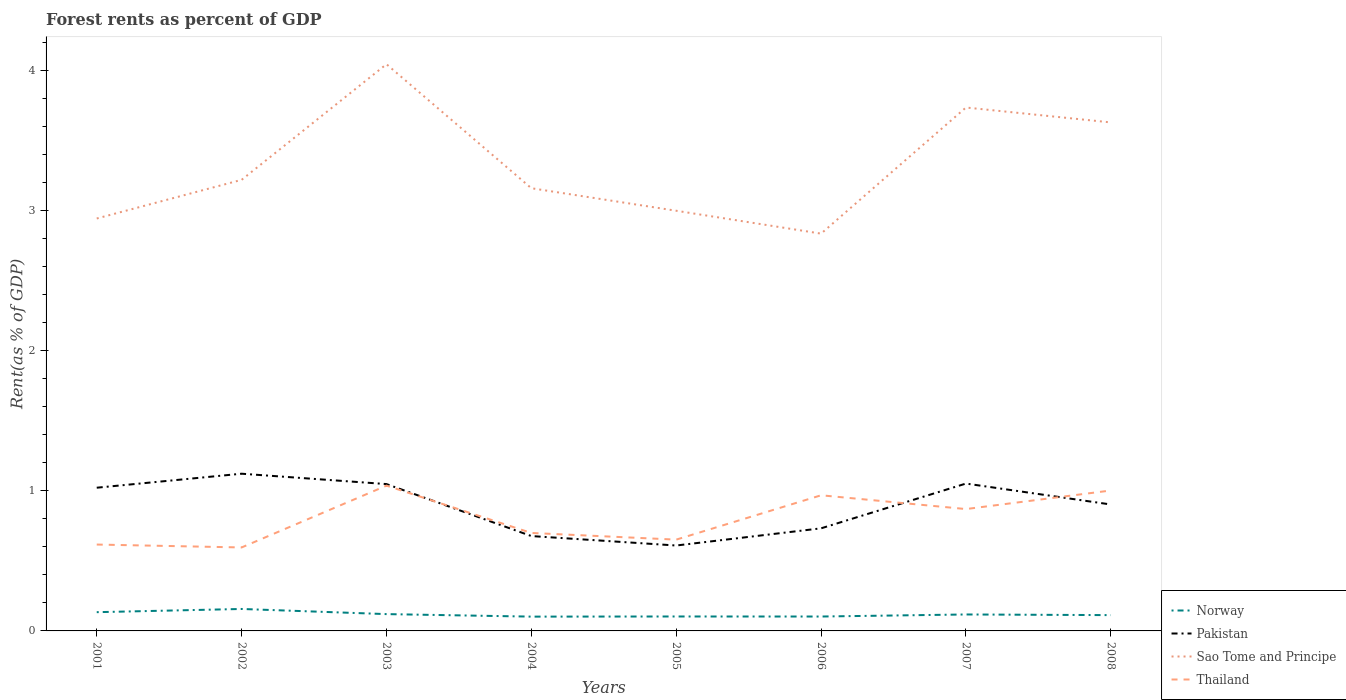How many different coloured lines are there?
Your response must be concise. 4. Does the line corresponding to Pakistan intersect with the line corresponding to Norway?
Make the answer very short. No. Across all years, what is the maximum forest rent in Thailand?
Provide a succinct answer. 0.6. In which year was the forest rent in Thailand maximum?
Your answer should be compact. 2002. What is the total forest rent in Thailand in the graph?
Ensure brevity in your answer.  0.02. What is the difference between the highest and the second highest forest rent in Thailand?
Ensure brevity in your answer.  0.44. Is the forest rent in Pakistan strictly greater than the forest rent in Sao Tome and Principe over the years?
Your answer should be compact. Yes. Does the graph contain any zero values?
Keep it short and to the point. No. How many legend labels are there?
Ensure brevity in your answer.  4. How are the legend labels stacked?
Provide a short and direct response. Vertical. What is the title of the graph?
Offer a terse response. Forest rents as percent of GDP. Does "American Samoa" appear as one of the legend labels in the graph?
Provide a succinct answer. No. What is the label or title of the Y-axis?
Offer a terse response. Rent(as % of GDP). What is the Rent(as % of GDP) in Norway in 2001?
Your answer should be compact. 0.13. What is the Rent(as % of GDP) of Pakistan in 2001?
Ensure brevity in your answer.  1.02. What is the Rent(as % of GDP) of Sao Tome and Principe in 2001?
Give a very brief answer. 2.95. What is the Rent(as % of GDP) in Thailand in 2001?
Your answer should be compact. 0.62. What is the Rent(as % of GDP) of Norway in 2002?
Provide a succinct answer. 0.16. What is the Rent(as % of GDP) in Pakistan in 2002?
Offer a terse response. 1.12. What is the Rent(as % of GDP) in Sao Tome and Principe in 2002?
Offer a terse response. 3.22. What is the Rent(as % of GDP) of Thailand in 2002?
Give a very brief answer. 0.6. What is the Rent(as % of GDP) of Norway in 2003?
Your response must be concise. 0.12. What is the Rent(as % of GDP) of Pakistan in 2003?
Your response must be concise. 1.05. What is the Rent(as % of GDP) of Sao Tome and Principe in 2003?
Offer a very short reply. 4.05. What is the Rent(as % of GDP) in Thailand in 2003?
Your answer should be compact. 1.04. What is the Rent(as % of GDP) in Norway in 2004?
Give a very brief answer. 0.1. What is the Rent(as % of GDP) in Pakistan in 2004?
Provide a succinct answer. 0.68. What is the Rent(as % of GDP) in Sao Tome and Principe in 2004?
Offer a very short reply. 3.16. What is the Rent(as % of GDP) in Thailand in 2004?
Provide a short and direct response. 0.7. What is the Rent(as % of GDP) in Norway in 2005?
Offer a terse response. 0.1. What is the Rent(as % of GDP) in Pakistan in 2005?
Keep it short and to the point. 0.61. What is the Rent(as % of GDP) in Sao Tome and Principe in 2005?
Offer a terse response. 3. What is the Rent(as % of GDP) in Thailand in 2005?
Give a very brief answer. 0.65. What is the Rent(as % of GDP) in Norway in 2006?
Keep it short and to the point. 0.1. What is the Rent(as % of GDP) in Pakistan in 2006?
Give a very brief answer. 0.73. What is the Rent(as % of GDP) in Sao Tome and Principe in 2006?
Ensure brevity in your answer.  2.84. What is the Rent(as % of GDP) of Thailand in 2006?
Offer a terse response. 0.97. What is the Rent(as % of GDP) of Norway in 2007?
Ensure brevity in your answer.  0.12. What is the Rent(as % of GDP) in Pakistan in 2007?
Keep it short and to the point. 1.05. What is the Rent(as % of GDP) of Sao Tome and Principe in 2007?
Provide a short and direct response. 3.74. What is the Rent(as % of GDP) of Thailand in 2007?
Give a very brief answer. 0.87. What is the Rent(as % of GDP) of Norway in 2008?
Your answer should be very brief. 0.11. What is the Rent(as % of GDP) of Pakistan in 2008?
Your answer should be very brief. 0.9. What is the Rent(as % of GDP) in Sao Tome and Principe in 2008?
Provide a succinct answer. 3.63. What is the Rent(as % of GDP) of Thailand in 2008?
Your response must be concise. 1. Across all years, what is the maximum Rent(as % of GDP) of Norway?
Ensure brevity in your answer.  0.16. Across all years, what is the maximum Rent(as % of GDP) of Pakistan?
Ensure brevity in your answer.  1.12. Across all years, what is the maximum Rent(as % of GDP) of Sao Tome and Principe?
Make the answer very short. 4.05. Across all years, what is the maximum Rent(as % of GDP) in Thailand?
Offer a very short reply. 1.04. Across all years, what is the minimum Rent(as % of GDP) in Norway?
Your answer should be very brief. 0.1. Across all years, what is the minimum Rent(as % of GDP) of Pakistan?
Make the answer very short. 0.61. Across all years, what is the minimum Rent(as % of GDP) in Sao Tome and Principe?
Give a very brief answer. 2.84. Across all years, what is the minimum Rent(as % of GDP) of Thailand?
Ensure brevity in your answer.  0.6. What is the total Rent(as % of GDP) of Norway in the graph?
Keep it short and to the point. 0.95. What is the total Rent(as % of GDP) in Pakistan in the graph?
Offer a very short reply. 7.17. What is the total Rent(as % of GDP) of Sao Tome and Principe in the graph?
Ensure brevity in your answer.  26.58. What is the total Rent(as % of GDP) of Thailand in the graph?
Provide a succinct answer. 6.44. What is the difference between the Rent(as % of GDP) in Norway in 2001 and that in 2002?
Give a very brief answer. -0.02. What is the difference between the Rent(as % of GDP) of Pakistan in 2001 and that in 2002?
Offer a very short reply. -0.1. What is the difference between the Rent(as % of GDP) of Sao Tome and Principe in 2001 and that in 2002?
Your answer should be compact. -0.28. What is the difference between the Rent(as % of GDP) in Thailand in 2001 and that in 2002?
Your response must be concise. 0.02. What is the difference between the Rent(as % of GDP) of Norway in 2001 and that in 2003?
Make the answer very short. 0.01. What is the difference between the Rent(as % of GDP) in Pakistan in 2001 and that in 2003?
Make the answer very short. -0.03. What is the difference between the Rent(as % of GDP) of Sao Tome and Principe in 2001 and that in 2003?
Your answer should be compact. -1.1. What is the difference between the Rent(as % of GDP) of Thailand in 2001 and that in 2003?
Keep it short and to the point. -0.42. What is the difference between the Rent(as % of GDP) of Norway in 2001 and that in 2004?
Offer a terse response. 0.03. What is the difference between the Rent(as % of GDP) in Pakistan in 2001 and that in 2004?
Give a very brief answer. 0.35. What is the difference between the Rent(as % of GDP) of Sao Tome and Principe in 2001 and that in 2004?
Your answer should be very brief. -0.22. What is the difference between the Rent(as % of GDP) of Thailand in 2001 and that in 2004?
Offer a terse response. -0.08. What is the difference between the Rent(as % of GDP) in Norway in 2001 and that in 2005?
Provide a short and direct response. 0.03. What is the difference between the Rent(as % of GDP) in Pakistan in 2001 and that in 2005?
Make the answer very short. 0.41. What is the difference between the Rent(as % of GDP) of Sao Tome and Principe in 2001 and that in 2005?
Give a very brief answer. -0.06. What is the difference between the Rent(as % of GDP) in Thailand in 2001 and that in 2005?
Your answer should be compact. -0.04. What is the difference between the Rent(as % of GDP) of Norway in 2001 and that in 2006?
Make the answer very short. 0.03. What is the difference between the Rent(as % of GDP) in Pakistan in 2001 and that in 2006?
Ensure brevity in your answer.  0.29. What is the difference between the Rent(as % of GDP) in Sao Tome and Principe in 2001 and that in 2006?
Provide a short and direct response. 0.11. What is the difference between the Rent(as % of GDP) of Thailand in 2001 and that in 2006?
Ensure brevity in your answer.  -0.35. What is the difference between the Rent(as % of GDP) in Norway in 2001 and that in 2007?
Provide a short and direct response. 0.02. What is the difference between the Rent(as % of GDP) in Pakistan in 2001 and that in 2007?
Keep it short and to the point. -0.03. What is the difference between the Rent(as % of GDP) of Sao Tome and Principe in 2001 and that in 2007?
Keep it short and to the point. -0.79. What is the difference between the Rent(as % of GDP) in Thailand in 2001 and that in 2007?
Your answer should be compact. -0.25. What is the difference between the Rent(as % of GDP) in Norway in 2001 and that in 2008?
Your response must be concise. 0.02. What is the difference between the Rent(as % of GDP) of Pakistan in 2001 and that in 2008?
Provide a short and direct response. 0.12. What is the difference between the Rent(as % of GDP) of Sao Tome and Principe in 2001 and that in 2008?
Provide a succinct answer. -0.69. What is the difference between the Rent(as % of GDP) in Thailand in 2001 and that in 2008?
Give a very brief answer. -0.39. What is the difference between the Rent(as % of GDP) in Norway in 2002 and that in 2003?
Provide a short and direct response. 0.04. What is the difference between the Rent(as % of GDP) of Pakistan in 2002 and that in 2003?
Offer a very short reply. 0.07. What is the difference between the Rent(as % of GDP) in Sao Tome and Principe in 2002 and that in 2003?
Keep it short and to the point. -0.83. What is the difference between the Rent(as % of GDP) in Thailand in 2002 and that in 2003?
Provide a succinct answer. -0.44. What is the difference between the Rent(as % of GDP) of Norway in 2002 and that in 2004?
Give a very brief answer. 0.05. What is the difference between the Rent(as % of GDP) of Pakistan in 2002 and that in 2004?
Make the answer very short. 0.45. What is the difference between the Rent(as % of GDP) in Sao Tome and Principe in 2002 and that in 2004?
Offer a very short reply. 0.06. What is the difference between the Rent(as % of GDP) of Thailand in 2002 and that in 2004?
Your answer should be very brief. -0.1. What is the difference between the Rent(as % of GDP) in Norway in 2002 and that in 2005?
Make the answer very short. 0.05. What is the difference between the Rent(as % of GDP) in Pakistan in 2002 and that in 2005?
Your answer should be very brief. 0.51. What is the difference between the Rent(as % of GDP) in Sao Tome and Principe in 2002 and that in 2005?
Offer a terse response. 0.22. What is the difference between the Rent(as % of GDP) of Thailand in 2002 and that in 2005?
Give a very brief answer. -0.06. What is the difference between the Rent(as % of GDP) of Norway in 2002 and that in 2006?
Your answer should be compact. 0.05. What is the difference between the Rent(as % of GDP) in Pakistan in 2002 and that in 2006?
Give a very brief answer. 0.39. What is the difference between the Rent(as % of GDP) of Sao Tome and Principe in 2002 and that in 2006?
Ensure brevity in your answer.  0.38. What is the difference between the Rent(as % of GDP) of Thailand in 2002 and that in 2006?
Your answer should be compact. -0.37. What is the difference between the Rent(as % of GDP) in Norway in 2002 and that in 2007?
Offer a very short reply. 0.04. What is the difference between the Rent(as % of GDP) of Pakistan in 2002 and that in 2007?
Give a very brief answer. 0.07. What is the difference between the Rent(as % of GDP) in Sao Tome and Principe in 2002 and that in 2007?
Your response must be concise. -0.52. What is the difference between the Rent(as % of GDP) in Thailand in 2002 and that in 2007?
Ensure brevity in your answer.  -0.27. What is the difference between the Rent(as % of GDP) in Norway in 2002 and that in 2008?
Offer a terse response. 0.04. What is the difference between the Rent(as % of GDP) in Pakistan in 2002 and that in 2008?
Your response must be concise. 0.22. What is the difference between the Rent(as % of GDP) in Sao Tome and Principe in 2002 and that in 2008?
Provide a short and direct response. -0.41. What is the difference between the Rent(as % of GDP) in Thailand in 2002 and that in 2008?
Give a very brief answer. -0.41. What is the difference between the Rent(as % of GDP) of Norway in 2003 and that in 2004?
Your response must be concise. 0.02. What is the difference between the Rent(as % of GDP) in Pakistan in 2003 and that in 2004?
Make the answer very short. 0.37. What is the difference between the Rent(as % of GDP) of Sao Tome and Principe in 2003 and that in 2004?
Your response must be concise. 0.89. What is the difference between the Rent(as % of GDP) in Thailand in 2003 and that in 2004?
Provide a short and direct response. 0.34. What is the difference between the Rent(as % of GDP) in Norway in 2003 and that in 2005?
Ensure brevity in your answer.  0.02. What is the difference between the Rent(as % of GDP) in Pakistan in 2003 and that in 2005?
Offer a terse response. 0.44. What is the difference between the Rent(as % of GDP) of Sao Tome and Principe in 2003 and that in 2005?
Ensure brevity in your answer.  1.05. What is the difference between the Rent(as % of GDP) in Thailand in 2003 and that in 2005?
Your response must be concise. 0.39. What is the difference between the Rent(as % of GDP) in Norway in 2003 and that in 2006?
Provide a short and direct response. 0.02. What is the difference between the Rent(as % of GDP) of Pakistan in 2003 and that in 2006?
Offer a terse response. 0.32. What is the difference between the Rent(as % of GDP) of Sao Tome and Principe in 2003 and that in 2006?
Offer a very short reply. 1.21. What is the difference between the Rent(as % of GDP) in Thailand in 2003 and that in 2006?
Your response must be concise. 0.07. What is the difference between the Rent(as % of GDP) of Norway in 2003 and that in 2007?
Ensure brevity in your answer.  0. What is the difference between the Rent(as % of GDP) of Pakistan in 2003 and that in 2007?
Your answer should be compact. -0. What is the difference between the Rent(as % of GDP) in Sao Tome and Principe in 2003 and that in 2007?
Offer a very short reply. 0.31. What is the difference between the Rent(as % of GDP) of Thailand in 2003 and that in 2007?
Keep it short and to the point. 0.17. What is the difference between the Rent(as % of GDP) of Norway in 2003 and that in 2008?
Your answer should be very brief. 0.01. What is the difference between the Rent(as % of GDP) in Pakistan in 2003 and that in 2008?
Make the answer very short. 0.15. What is the difference between the Rent(as % of GDP) of Sao Tome and Principe in 2003 and that in 2008?
Provide a succinct answer. 0.42. What is the difference between the Rent(as % of GDP) of Thailand in 2003 and that in 2008?
Keep it short and to the point. 0.03. What is the difference between the Rent(as % of GDP) of Norway in 2004 and that in 2005?
Give a very brief answer. -0. What is the difference between the Rent(as % of GDP) in Pakistan in 2004 and that in 2005?
Your answer should be compact. 0.07. What is the difference between the Rent(as % of GDP) of Sao Tome and Principe in 2004 and that in 2005?
Give a very brief answer. 0.16. What is the difference between the Rent(as % of GDP) in Thailand in 2004 and that in 2005?
Make the answer very short. 0.05. What is the difference between the Rent(as % of GDP) of Norway in 2004 and that in 2006?
Offer a terse response. -0. What is the difference between the Rent(as % of GDP) in Pakistan in 2004 and that in 2006?
Make the answer very short. -0.06. What is the difference between the Rent(as % of GDP) of Sao Tome and Principe in 2004 and that in 2006?
Provide a succinct answer. 0.32. What is the difference between the Rent(as % of GDP) of Thailand in 2004 and that in 2006?
Keep it short and to the point. -0.27. What is the difference between the Rent(as % of GDP) of Norway in 2004 and that in 2007?
Offer a terse response. -0.02. What is the difference between the Rent(as % of GDP) of Pakistan in 2004 and that in 2007?
Provide a succinct answer. -0.38. What is the difference between the Rent(as % of GDP) in Sao Tome and Principe in 2004 and that in 2007?
Your response must be concise. -0.58. What is the difference between the Rent(as % of GDP) of Thailand in 2004 and that in 2007?
Keep it short and to the point. -0.17. What is the difference between the Rent(as % of GDP) of Norway in 2004 and that in 2008?
Give a very brief answer. -0.01. What is the difference between the Rent(as % of GDP) in Pakistan in 2004 and that in 2008?
Provide a short and direct response. -0.23. What is the difference between the Rent(as % of GDP) in Sao Tome and Principe in 2004 and that in 2008?
Your response must be concise. -0.47. What is the difference between the Rent(as % of GDP) of Thailand in 2004 and that in 2008?
Give a very brief answer. -0.3. What is the difference between the Rent(as % of GDP) in Norway in 2005 and that in 2006?
Your answer should be very brief. 0. What is the difference between the Rent(as % of GDP) of Pakistan in 2005 and that in 2006?
Your response must be concise. -0.12. What is the difference between the Rent(as % of GDP) in Sao Tome and Principe in 2005 and that in 2006?
Provide a short and direct response. 0.16. What is the difference between the Rent(as % of GDP) of Thailand in 2005 and that in 2006?
Provide a succinct answer. -0.32. What is the difference between the Rent(as % of GDP) in Norway in 2005 and that in 2007?
Keep it short and to the point. -0.01. What is the difference between the Rent(as % of GDP) in Pakistan in 2005 and that in 2007?
Your response must be concise. -0.44. What is the difference between the Rent(as % of GDP) of Sao Tome and Principe in 2005 and that in 2007?
Ensure brevity in your answer.  -0.74. What is the difference between the Rent(as % of GDP) of Thailand in 2005 and that in 2007?
Keep it short and to the point. -0.22. What is the difference between the Rent(as % of GDP) in Norway in 2005 and that in 2008?
Keep it short and to the point. -0.01. What is the difference between the Rent(as % of GDP) in Pakistan in 2005 and that in 2008?
Make the answer very short. -0.29. What is the difference between the Rent(as % of GDP) in Sao Tome and Principe in 2005 and that in 2008?
Your response must be concise. -0.63. What is the difference between the Rent(as % of GDP) in Thailand in 2005 and that in 2008?
Make the answer very short. -0.35. What is the difference between the Rent(as % of GDP) in Norway in 2006 and that in 2007?
Offer a very short reply. -0.01. What is the difference between the Rent(as % of GDP) of Pakistan in 2006 and that in 2007?
Your response must be concise. -0.32. What is the difference between the Rent(as % of GDP) of Sao Tome and Principe in 2006 and that in 2007?
Provide a short and direct response. -0.9. What is the difference between the Rent(as % of GDP) in Thailand in 2006 and that in 2007?
Provide a short and direct response. 0.1. What is the difference between the Rent(as % of GDP) of Norway in 2006 and that in 2008?
Offer a very short reply. -0.01. What is the difference between the Rent(as % of GDP) in Pakistan in 2006 and that in 2008?
Give a very brief answer. -0.17. What is the difference between the Rent(as % of GDP) in Sao Tome and Principe in 2006 and that in 2008?
Make the answer very short. -0.79. What is the difference between the Rent(as % of GDP) in Thailand in 2006 and that in 2008?
Your answer should be compact. -0.03. What is the difference between the Rent(as % of GDP) in Norway in 2007 and that in 2008?
Give a very brief answer. 0. What is the difference between the Rent(as % of GDP) in Pakistan in 2007 and that in 2008?
Keep it short and to the point. 0.15. What is the difference between the Rent(as % of GDP) in Sao Tome and Principe in 2007 and that in 2008?
Provide a succinct answer. 0.11. What is the difference between the Rent(as % of GDP) in Thailand in 2007 and that in 2008?
Keep it short and to the point. -0.13. What is the difference between the Rent(as % of GDP) in Norway in 2001 and the Rent(as % of GDP) in Pakistan in 2002?
Offer a very short reply. -0.99. What is the difference between the Rent(as % of GDP) in Norway in 2001 and the Rent(as % of GDP) in Sao Tome and Principe in 2002?
Your answer should be very brief. -3.09. What is the difference between the Rent(as % of GDP) of Norway in 2001 and the Rent(as % of GDP) of Thailand in 2002?
Provide a succinct answer. -0.46. What is the difference between the Rent(as % of GDP) of Pakistan in 2001 and the Rent(as % of GDP) of Sao Tome and Principe in 2002?
Your answer should be compact. -2.2. What is the difference between the Rent(as % of GDP) in Pakistan in 2001 and the Rent(as % of GDP) in Thailand in 2002?
Offer a terse response. 0.43. What is the difference between the Rent(as % of GDP) of Sao Tome and Principe in 2001 and the Rent(as % of GDP) of Thailand in 2002?
Your response must be concise. 2.35. What is the difference between the Rent(as % of GDP) of Norway in 2001 and the Rent(as % of GDP) of Pakistan in 2003?
Ensure brevity in your answer.  -0.91. What is the difference between the Rent(as % of GDP) in Norway in 2001 and the Rent(as % of GDP) in Sao Tome and Principe in 2003?
Ensure brevity in your answer.  -3.91. What is the difference between the Rent(as % of GDP) in Norway in 2001 and the Rent(as % of GDP) in Thailand in 2003?
Your response must be concise. -0.9. What is the difference between the Rent(as % of GDP) of Pakistan in 2001 and the Rent(as % of GDP) of Sao Tome and Principe in 2003?
Your answer should be compact. -3.02. What is the difference between the Rent(as % of GDP) of Pakistan in 2001 and the Rent(as % of GDP) of Thailand in 2003?
Make the answer very short. -0.01. What is the difference between the Rent(as % of GDP) in Sao Tome and Principe in 2001 and the Rent(as % of GDP) in Thailand in 2003?
Provide a short and direct response. 1.91. What is the difference between the Rent(as % of GDP) of Norway in 2001 and the Rent(as % of GDP) of Pakistan in 2004?
Keep it short and to the point. -0.54. What is the difference between the Rent(as % of GDP) in Norway in 2001 and the Rent(as % of GDP) in Sao Tome and Principe in 2004?
Your answer should be compact. -3.03. What is the difference between the Rent(as % of GDP) in Norway in 2001 and the Rent(as % of GDP) in Thailand in 2004?
Provide a succinct answer. -0.57. What is the difference between the Rent(as % of GDP) in Pakistan in 2001 and the Rent(as % of GDP) in Sao Tome and Principe in 2004?
Offer a terse response. -2.14. What is the difference between the Rent(as % of GDP) of Pakistan in 2001 and the Rent(as % of GDP) of Thailand in 2004?
Ensure brevity in your answer.  0.32. What is the difference between the Rent(as % of GDP) in Sao Tome and Principe in 2001 and the Rent(as % of GDP) in Thailand in 2004?
Your answer should be compact. 2.25. What is the difference between the Rent(as % of GDP) in Norway in 2001 and the Rent(as % of GDP) in Pakistan in 2005?
Offer a very short reply. -0.48. What is the difference between the Rent(as % of GDP) in Norway in 2001 and the Rent(as % of GDP) in Sao Tome and Principe in 2005?
Keep it short and to the point. -2.87. What is the difference between the Rent(as % of GDP) in Norway in 2001 and the Rent(as % of GDP) in Thailand in 2005?
Offer a very short reply. -0.52. What is the difference between the Rent(as % of GDP) in Pakistan in 2001 and the Rent(as % of GDP) in Sao Tome and Principe in 2005?
Give a very brief answer. -1.98. What is the difference between the Rent(as % of GDP) of Pakistan in 2001 and the Rent(as % of GDP) of Thailand in 2005?
Your answer should be very brief. 0.37. What is the difference between the Rent(as % of GDP) in Sao Tome and Principe in 2001 and the Rent(as % of GDP) in Thailand in 2005?
Your answer should be very brief. 2.29. What is the difference between the Rent(as % of GDP) in Norway in 2001 and the Rent(as % of GDP) in Pakistan in 2006?
Your response must be concise. -0.6. What is the difference between the Rent(as % of GDP) of Norway in 2001 and the Rent(as % of GDP) of Sao Tome and Principe in 2006?
Keep it short and to the point. -2.7. What is the difference between the Rent(as % of GDP) in Norway in 2001 and the Rent(as % of GDP) in Thailand in 2006?
Give a very brief answer. -0.83. What is the difference between the Rent(as % of GDP) in Pakistan in 2001 and the Rent(as % of GDP) in Sao Tome and Principe in 2006?
Offer a very short reply. -1.81. What is the difference between the Rent(as % of GDP) of Pakistan in 2001 and the Rent(as % of GDP) of Thailand in 2006?
Keep it short and to the point. 0.05. What is the difference between the Rent(as % of GDP) in Sao Tome and Principe in 2001 and the Rent(as % of GDP) in Thailand in 2006?
Ensure brevity in your answer.  1.98. What is the difference between the Rent(as % of GDP) of Norway in 2001 and the Rent(as % of GDP) of Pakistan in 2007?
Keep it short and to the point. -0.92. What is the difference between the Rent(as % of GDP) of Norway in 2001 and the Rent(as % of GDP) of Sao Tome and Principe in 2007?
Give a very brief answer. -3.6. What is the difference between the Rent(as % of GDP) in Norway in 2001 and the Rent(as % of GDP) in Thailand in 2007?
Ensure brevity in your answer.  -0.74. What is the difference between the Rent(as % of GDP) of Pakistan in 2001 and the Rent(as % of GDP) of Sao Tome and Principe in 2007?
Keep it short and to the point. -2.72. What is the difference between the Rent(as % of GDP) in Pakistan in 2001 and the Rent(as % of GDP) in Thailand in 2007?
Your answer should be compact. 0.15. What is the difference between the Rent(as % of GDP) of Sao Tome and Principe in 2001 and the Rent(as % of GDP) of Thailand in 2007?
Your response must be concise. 2.08. What is the difference between the Rent(as % of GDP) in Norway in 2001 and the Rent(as % of GDP) in Pakistan in 2008?
Your answer should be compact. -0.77. What is the difference between the Rent(as % of GDP) in Norway in 2001 and the Rent(as % of GDP) in Sao Tome and Principe in 2008?
Give a very brief answer. -3.5. What is the difference between the Rent(as % of GDP) of Norway in 2001 and the Rent(as % of GDP) of Thailand in 2008?
Make the answer very short. -0.87. What is the difference between the Rent(as % of GDP) of Pakistan in 2001 and the Rent(as % of GDP) of Sao Tome and Principe in 2008?
Keep it short and to the point. -2.61. What is the difference between the Rent(as % of GDP) of Pakistan in 2001 and the Rent(as % of GDP) of Thailand in 2008?
Your answer should be compact. 0.02. What is the difference between the Rent(as % of GDP) in Sao Tome and Principe in 2001 and the Rent(as % of GDP) in Thailand in 2008?
Provide a succinct answer. 1.94. What is the difference between the Rent(as % of GDP) of Norway in 2002 and the Rent(as % of GDP) of Pakistan in 2003?
Offer a very short reply. -0.89. What is the difference between the Rent(as % of GDP) in Norway in 2002 and the Rent(as % of GDP) in Sao Tome and Principe in 2003?
Your response must be concise. -3.89. What is the difference between the Rent(as % of GDP) of Norway in 2002 and the Rent(as % of GDP) of Thailand in 2003?
Your answer should be very brief. -0.88. What is the difference between the Rent(as % of GDP) in Pakistan in 2002 and the Rent(as % of GDP) in Sao Tome and Principe in 2003?
Provide a short and direct response. -2.92. What is the difference between the Rent(as % of GDP) of Pakistan in 2002 and the Rent(as % of GDP) of Thailand in 2003?
Provide a short and direct response. 0.09. What is the difference between the Rent(as % of GDP) of Sao Tome and Principe in 2002 and the Rent(as % of GDP) of Thailand in 2003?
Keep it short and to the point. 2.18. What is the difference between the Rent(as % of GDP) of Norway in 2002 and the Rent(as % of GDP) of Pakistan in 2004?
Ensure brevity in your answer.  -0.52. What is the difference between the Rent(as % of GDP) in Norway in 2002 and the Rent(as % of GDP) in Sao Tome and Principe in 2004?
Your answer should be very brief. -3. What is the difference between the Rent(as % of GDP) of Norway in 2002 and the Rent(as % of GDP) of Thailand in 2004?
Your response must be concise. -0.54. What is the difference between the Rent(as % of GDP) in Pakistan in 2002 and the Rent(as % of GDP) in Sao Tome and Principe in 2004?
Give a very brief answer. -2.04. What is the difference between the Rent(as % of GDP) in Pakistan in 2002 and the Rent(as % of GDP) in Thailand in 2004?
Give a very brief answer. 0.42. What is the difference between the Rent(as % of GDP) of Sao Tome and Principe in 2002 and the Rent(as % of GDP) of Thailand in 2004?
Ensure brevity in your answer.  2.52. What is the difference between the Rent(as % of GDP) of Norway in 2002 and the Rent(as % of GDP) of Pakistan in 2005?
Offer a very short reply. -0.45. What is the difference between the Rent(as % of GDP) in Norway in 2002 and the Rent(as % of GDP) in Sao Tome and Principe in 2005?
Provide a succinct answer. -2.84. What is the difference between the Rent(as % of GDP) in Norway in 2002 and the Rent(as % of GDP) in Thailand in 2005?
Give a very brief answer. -0.5. What is the difference between the Rent(as % of GDP) in Pakistan in 2002 and the Rent(as % of GDP) in Sao Tome and Principe in 2005?
Give a very brief answer. -1.88. What is the difference between the Rent(as % of GDP) of Pakistan in 2002 and the Rent(as % of GDP) of Thailand in 2005?
Provide a succinct answer. 0.47. What is the difference between the Rent(as % of GDP) of Sao Tome and Principe in 2002 and the Rent(as % of GDP) of Thailand in 2005?
Offer a terse response. 2.57. What is the difference between the Rent(as % of GDP) in Norway in 2002 and the Rent(as % of GDP) in Pakistan in 2006?
Keep it short and to the point. -0.58. What is the difference between the Rent(as % of GDP) in Norway in 2002 and the Rent(as % of GDP) in Sao Tome and Principe in 2006?
Make the answer very short. -2.68. What is the difference between the Rent(as % of GDP) in Norway in 2002 and the Rent(as % of GDP) in Thailand in 2006?
Ensure brevity in your answer.  -0.81. What is the difference between the Rent(as % of GDP) in Pakistan in 2002 and the Rent(as % of GDP) in Sao Tome and Principe in 2006?
Make the answer very short. -1.71. What is the difference between the Rent(as % of GDP) of Pakistan in 2002 and the Rent(as % of GDP) of Thailand in 2006?
Make the answer very short. 0.15. What is the difference between the Rent(as % of GDP) of Sao Tome and Principe in 2002 and the Rent(as % of GDP) of Thailand in 2006?
Offer a very short reply. 2.25. What is the difference between the Rent(as % of GDP) in Norway in 2002 and the Rent(as % of GDP) in Pakistan in 2007?
Keep it short and to the point. -0.9. What is the difference between the Rent(as % of GDP) of Norway in 2002 and the Rent(as % of GDP) of Sao Tome and Principe in 2007?
Give a very brief answer. -3.58. What is the difference between the Rent(as % of GDP) in Norway in 2002 and the Rent(as % of GDP) in Thailand in 2007?
Your response must be concise. -0.71. What is the difference between the Rent(as % of GDP) of Pakistan in 2002 and the Rent(as % of GDP) of Sao Tome and Principe in 2007?
Your answer should be very brief. -2.62. What is the difference between the Rent(as % of GDP) in Pakistan in 2002 and the Rent(as % of GDP) in Thailand in 2007?
Offer a very short reply. 0.25. What is the difference between the Rent(as % of GDP) of Sao Tome and Principe in 2002 and the Rent(as % of GDP) of Thailand in 2007?
Give a very brief answer. 2.35. What is the difference between the Rent(as % of GDP) of Norway in 2002 and the Rent(as % of GDP) of Pakistan in 2008?
Offer a very short reply. -0.75. What is the difference between the Rent(as % of GDP) in Norway in 2002 and the Rent(as % of GDP) in Sao Tome and Principe in 2008?
Your answer should be compact. -3.47. What is the difference between the Rent(as % of GDP) in Norway in 2002 and the Rent(as % of GDP) in Thailand in 2008?
Your answer should be very brief. -0.85. What is the difference between the Rent(as % of GDP) in Pakistan in 2002 and the Rent(as % of GDP) in Sao Tome and Principe in 2008?
Provide a short and direct response. -2.51. What is the difference between the Rent(as % of GDP) in Pakistan in 2002 and the Rent(as % of GDP) in Thailand in 2008?
Your answer should be very brief. 0.12. What is the difference between the Rent(as % of GDP) of Sao Tome and Principe in 2002 and the Rent(as % of GDP) of Thailand in 2008?
Your response must be concise. 2.22. What is the difference between the Rent(as % of GDP) in Norway in 2003 and the Rent(as % of GDP) in Pakistan in 2004?
Give a very brief answer. -0.56. What is the difference between the Rent(as % of GDP) of Norway in 2003 and the Rent(as % of GDP) of Sao Tome and Principe in 2004?
Provide a short and direct response. -3.04. What is the difference between the Rent(as % of GDP) in Norway in 2003 and the Rent(as % of GDP) in Thailand in 2004?
Provide a succinct answer. -0.58. What is the difference between the Rent(as % of GDP) in Pakistan in 2003 and the Rent(as % of GDP) in Sao Tome and Principe in 2004?
Your response must be concise. -2.11. What is the difference between the Rent(as % of GDP) of Pakistan in 2003 and the Rent(as % of GDP) of Thailand in 2004?
Make the answer very short. 0.35. What is the difference between the Rent(as % of GDP) of Sao Tome and Principe in 2003 and the Rent(as % of GDP) of Thailand in 2004?
Offer a terse response. 3.35. What is the difference between the Rent(as % of GDP) in Norway in 2003 and the Rent(as % of GDP) in Pakistan in 2005?
Offer a very short reply. -0.49. What is the difference between the Rent(as % of GDP) of Norway in 2003 and the Rent(as % of GDP) of Sao Tome and Principe in 2005?
Provide a short and direct response. -2.88. What is the difference between the Rent(as % of GDP) of Norway in 2003 and the Rent(as % of GDP) of Thailand in 2005?
Ensure brevity in your answer.  -0.53. What is the difference between the Rent(as % of GDP) of Pakistan in 2003 and the Rent(as % of GDP) of Sao Tome and Principe in 2005?
Keep it short and to the point. -1.95. What is the difference between the Rent(as % of GDP) of Pakistan in 2003 and the Rent(as % of GDP) of Thailand in 2005?
Offer a very short reply. 0.4. What is the difference between the Rent(as % of GDP) of Sao Tome and Principe in 2003 and the Rent(as % of GDP) of Thailand in 2005?
Your answer should be very brief. 3.4. What is the difference between the Rent(as % of GDP) in Norway in 2003 and the Rent(as % of GDP) in Pakistan in 2006?
Your response must be concise. -0.61. What is the difference between the Rent(as % of GDP) in Norway in 2003 and the Rent(as % of GDP) in Sao Tome and Principe in 2006?
Make the answer very short. -2.72. What is the difference between the Rent(as % of GDP) in Norway in 2003 and the Rent(as % of GDP) in Thailand in 2006?
Provide a short and direct response. -0.85. What is the difference between the Rent(as % of GDP) in Pakistan in 2003 and the Rent(as % of GDP) in Sao Tome and Principe in 2006?
Your answer should be compact. -1.79. What is the difference between the Rent(as % of GDP) in Pakistan in 2003 and the Rent(as % of GDP) in Thailand in 2006?
Provide a short and direct response. 0.08. What is the difference between the Rent(as % of GDP) in Sao Tome and Principe in 2003 and the Rent(as % of GDP) in Thailand in 2006?
Offer a very short reply. 3.08. What is the difference between the Rent(as % of GDP) of Norway in 2003 and the Rent(as % of GDP) of Pakistan in 2007?
Provide a short and direct response. -0.93. What is the difference between the Rent(as % of GDP) in Norway in 2003 and the Rent(as % of GDP) in Sao Tome and Principe in 2007?
Your answer should be compact. -3.62. What is the difference between the Rent(as % of GDP) of Norway in 2003 and the Rent(as % of GDP) of Thailand in 2007?
Provide a succinct answer. -0.75. What is the difference between the Rent(as % of GDP) in Pakistan in 2003 and the Rent(as % of GDP) in Sao Tome and Principe in 2007?
Provide a short and direct response. -2.69. What is the difference between the Rent(as % of GDP) in Pakistan in 2003 and the Rent(as % of GDP) in Thailand in 2007?
Make the answer very short. 0.18. What is the difference between the Rent(as % of GDP) of Sao Tome and Principe in 2003 and the Rent(as % of GDP) of Thailand in 2007?
Offer a very short reply. 3.18. What is the difference between the Rent(as % of GDP) in Norway in 2003 and the Rent(as % of GDP) in Pakistan in 2008?
Ensure brevity in your answer.  -0.78. What is the difference between the Rent(as % of GDP) in Norway in 2003 and the Rent(as % of GDP) in Sao Tome and Principe in 2008?
Your answer should be very brief. -3.51. What is the difference between the Rent(as % of GDP) of Norway in 2003 and the Rent(as % of GDP) of Thailand in 2008?
Ensure brevity in your answer.  -0.88. What is the difference between the Rent(as % of GDP) in Pakistan in 2003 and the Rent(as % of GDP) in Sao Tome and Principe in 2008?
Your answer should be compact. -2.58. What is the difference between the Rent(as % of GDP) in Pakistan in 2003 and the Rent(as % of GDP) in Thailand in 2008?
Offer a terse response. 0.05. What is the difference between the Rent(as % of GDP) in Sao Tome and Principe in 2003 and the Rent(as % of GDP) in Thailand in 2008?
Give a very brief answer. 3.04. What is the difference between the Rent(as % of GDP) in Norway in 2004 and the Rent(as % of GDP) in Pakistan in 2005?
Provide a short and direct response. -0.51. What is the difference between the Rent(as % of GDP) in Norway in 2004 and the Rent(as % of GDP) in Sao Tome and Principe in 2005?
Provide a succinct answer. -2.9. What is the difference between the Rent(as % of GDP) of Norway in 2004 and the Rent(as % of GDP) of Thailand in 2005?
Offer a terse response. -0.55. What is the difference between the Rent(as % of GDP) in Pakistan in 2004 and the Rent(as % of GDP) in Sao Tome and Principe in 2005?
Your answer should be very brief. -2.32. What is the difference between the Rent(as % of GDP) of Pakistan in 2004 and the Rent(as % of GDP) of Thailand in 2005?
Your response must be concise. 0.03. What is the difference between the Rent(as % of GDP) in Sao Tome and Principe in 2004 and the Rent(as % of GDP) in Thailand in 2005?
Provide a short and direct response. 2.51. What is the difference between the Rent(as % of GDP) of Norway in 2004 and the Rent(as % of GDP) of Pakistan in 2006?
Make the answer very short. -0.63. What is the difference between the Rent(as % of GDP) of Norway in 2004 and the Rent(as % of GDP) of Sao Tome and Principe in 2006?
Give a very brief answer. -2.74. What is the difference between the Rent(as % of GDP) of Norway in 2004 and the Rent(as % of GDP) of Thailand in 2006?
Your answer should be compact. -0.87. What is the difference between the Rent(as % of GDP) of Pakistan in 2004 and the Rent(as % of GDP) of Sao Tome and Principe in 2006?
Your answer should be very brief. -2.16. What is the difference between the Rent(as % of GDP) in Pakistan in 2004 and the Rent(as % of GDP) in Thailand in 2006?
Offer a very short reply. -0.29. What is the difference between the Rent(as % of GDP) of Sao Tome and Principe in 2004 and the Rent(as % of GDP) of Thailand in 2006?
Keep it short and to the point. 2.19. What is the difference between the Rent(as % of GDP) in Norway in 2004 and the Rent(as % of GDP) in Pakistan in 2007?
Provide a short and direct response. -0.95. What is the difference between the Rent(as % of GDP) in Norway in 2004 and the Rent(as % of GDP) in Sao Tome and Principe in 2007?
Offer a very short reply. -3.64. What is the difference between the Rent(as % of GDP) of Norway in 2004 and the Rent(as % of GDP) of Thailand in 2007?
Make the answer very short. -0.77. What is the difference between the Rent(as % of GDP) in Pakistan in 2004 and the Rent(as % of GDP) in Sao Tome and Principe in 2007?
Give a very brief answer. -3.06. What is the difference between the Rent(as % of GDP) in Pakistan in 2004 and the Rent(as % of GDP) in Thailand in 2007?
Your answer should be very brief. -0.19. What is the difference between the Rent(as % of GDP) of Sao Tome and Principe in 2004 and the Rent(as % of GDP) of Thailand in 2007?
Ensure brevity in your answer.  2.29. What is the difference between the Rent(as % of GDP) of Norway in 2004 and the Rent(as % of GDP) of Pakistan in 2008?
Provide a succinct answer. -0.8. What is the difference between the Rent(as % of GDP) of Norway in 2004 and the Rent(as % of GDP) of Sao Tome and Principe in 2008?
Provide a succinct answer. -3.53. What is the difference between the Rent(as % of GDP) in Norway in 2004 and the Rent(as % of GDP) in Thailand in 2008?
Provide a succinct answer. -0.9. What is the difference between the Rent(as % of GDP) in Pakistan in 2004 and the Rent(as % of GDP) in Sao Tome and Principe in 2008?
Ensure brevity in your answer.  -2.95. What is the difference between the Rent(as % of GDP) of Pakistan in 2004 and the Rent(as % of GDP) of Thailand in 2008?
Give a very brief answer. -0.33. What is the difference between the Rent(as % of GDP) of Sao Tome and Principe in 2004 and the Rent(as % of GDP) of Thailand in 2008?
Your answer should be compact. 2.16. What is the difference between the Rent(as % of GDP) in Norway in 2005 and the Rent(as % of GDP) in Pakistan in 2006?
Make the answer very short. -0.63. What is the difference between the Rent(as % of GDP) of Norway in 2005 and the Rent(as % of GDP) of Sao Tome and Principe in 2006?
Ensure brevity in your answer.  -2.73. What is the difference between the Rent(as % of GDP) in Norway in 2005 and the Rent(as % of GDP) in Thailand in 2006?
Provide a short and direct response. -0.87. What is the difference between the Rent(as % of GDP) in Pakistan in 2005 and the Rent(as % of GDP) in Sao Tome and Principe in 2006?
Offer a very short reply. -2.23. What is the difference between the Rent(as % of GDP) of Pakistan in 2005 and the Rent(as % of GDP) of Thailand in 2006?
Your answer should be compact. -0.36. What is the difference between the Rent(as % of GDP) of Sao Tome and Principe in 2005 and the Rent(as % of GDP) of Thailand in 2006?
Offer a terse response. 2.03. What is the difference between the Rent(as % of GDP) in Norway in 2005 and the Rent(as % of GDP) in Pakistan in 2007?
Provide a succinct answer. -0.95. What is the difference between the Rent(as % of GDP) in Norway in 2005 and the Rent(as % of GDP) in Sao Tome and Principe in 2007?
Make the answer very short. -3.64. What is the difference between the Rent(as % of GDP) of Norway in 2005 and the Rent(as % of GDP) of Thailand in 2007?
Give a very brief answer. -0.77. What is the difference between the Rent(as % of GDP) in Pakistan in 2005 and the Rent(as % of GDP) in Sao Tome and Principe in 2007?
Provide a succinct answer. -3.13. What is the difference between the Rent(as % of GDP) of Pakistan in 2005 and the Rent(as % of GDP) of Thailand in 2007?
Give a very brief answer. -0.26. What is the difference between the Rent(as % of GDP) of Sao Tome and Principe in 2005 and the Rent(as % of GDP) of Thailand in 2007?
Provide a short and direct response. 2.13. What is the difference between the Rent(as % of GDP) of Norway in 2005 and the Rent(as % of GDP) of Pakistan in 2008?
Offer a terse response. -0.8. What is the difference between the Rent(as % of GDP) of Norway in 2005 and the Rent(as % of GDP) of Sao Tome and Principe in 2008?
Your response must be concise. -3.53. What is the difference between the Rent(as % of GDP) of Norway in 2005 and the Rent(as % of GDP) of Thailand in 2008?
Make the answer very short. -0.9. What is the difference between the Rent(as % of GDP) in Pakistan in 2005 and the Rent(as % of GDP) in Sao Tome and Principe in 2008?
Provide a short and direct response. -3.02. What is the difference between the Rent(as % of GDP) in Pakistan in 2005 and the Rent(as % of GDP) in Thailand in 2008?
Make the answer very short. -0.39. What is the difference between the Rent(as % of GDP) in Sao Tome and Principe in 2005 and the Rent(as % of GDP) in Thailand in 2008?
Provide a succinct answer. 2. What is the difference between the Rent(as % of GDP) of Norway in 2006 and the Rent(as % of GDP) of Pakistan in 2007?
Provide a succinct answer. -0.95. What is the difference between the Rent(as % of GDP) of Norway in 2006 and the Rent(as % of GDP) of Sao Tome and Principe in 2007?
Provide a succinct answer. -3.64. What is the difference between the Rent(as % of GDP) in Norway in 2006 and the Rent(as % of GDP) in Thailand in 2007?
Your response must be concise. -0.77. What is the difference between the Rent(as % of GDP) of Pakistan in 2006 and the Rent(as % of GDP) of Sao Tome and Principe in 2007?
Provide a short and direct response. -3.01. What is the difference between the Rent(as % of GDP) of Pakistan in 2006 and the Rent(as % of GDP) of Thailand in 2007?
Offer a very short reply. -0.14. What is the difference between the Rent(as % of GDP) of Sao Tome and Principe in 2006 and the Rent(as % of GDP) of Thailand in 2007?
Your answer should be compact. 1.97. What is the difference between the Rent(as % of GDP) of Norway in 2006 and the Rent(as % of GDP) of Pakistan in 2008?
Make the answer very short. -0.8. What is the difference between the Rent(as % of GDP) in Norway in 2006 and the Rent(as % of GDP) in Sao Tome and Principe in 2008?
Offer a terse response. -3.53. What is the difference between the Rent(as % of GDP) in Norway in 2006 and the Rent(as % of GDP) in Thailand in 2008?
Provide a succinct answer. -0.9. What is the difference between the Rent(as % of GDP) in Pakistan in 2006 and the Rent(as % of GDP) in Sao Tome and Principe in 2008?
Offer a very short reply. -2.9. What is the difference between the Rent(as % of GDP) in Pakistan in 2006 and the Rent(as % of GDP) in Thailand in 2008?
Provide a succinct answer. -0.27. What is the difference between the Rent(as % of GDP) in Sao Tome and Principe in 2006 and the Rent(as % of GDP) in Thailand in 2008?
Provide a short and direct response. 1.83. What is the difference between the Rent(as % of GDP) in Norway in 2007 and the Rent(as % of GDP) in Pakistan in 2008?
Your answer should be compact. -0.79. What is the difference between the Rent(as % of GDP) of Norway in 2007 and the Rent(as % of GDP) of Sao Tome and Principe in 2008?
Your response must be concise. -3.51. What is the difference between the Rent(as % of GDP) in Norway in 2007 and the Rent(as % of GDP) in Thailand in 2008?
Provide a short and direct response. -0.89. What is the difference between the Rent(as % of GDP) of Pakistan in 2007 and the Rent(as % of GDP) of Sao Tome and Principe in 2008?
Provide a short and direct response. -2.58. What is the difference between the Rent(as % of GDP) in Pakistan in 2007 and the Rent(as % of GDP) in Thailand in 2008?
Ensure brevity in your answer.  0.05. What is the difference between the Rent(as % of GDP) in Sao Tome and Principe in 2007 and the Rent(as % of GDP) in Thailand in 2008?
Provide a short and direct response. 2.74. What is the average Rent(as % of GDP) in Norway per year?
Ensure brevity in your answer.  0.12. What is the average Rent(as % of GDP) of Pakistan per year?
Provide a succinct answer. 0.9. What is the average Rent(as % of GDP) in Sao Tome and Principe per year?
Make the answer very short. 3.32. What is the average Rent(as % of GDP) of Thailand per year?
Offer a very short reply. 0.81. In the year 2001, what is the difference between the Rent(as % of GDP) in Norway and Rent(as % of GDP) in Pakistan?
Your answer should be compact. -0.89. In the year 2001, what is the difference between the Rent(as % of GDP) of Norway and Rent(as % of GDP) of Sao Tome and Principe?
Offer a terse response. -2.81. In the year 2001, what is the difference between the Rent(as % of GDP) in Norway and Rent(as % of GDP) in Thailand?
Give a very brief answer. -0.48. In the year 2001, what is the difference between the Rent(as % of GDP) of Pakistan and Rent(as % of GDP) of Sao Tome and Principe?
Your response must be concise. -1.92. In the year 2001, what is the difference between the Rent(as % of GDP) of Pakistan and Rent(as % of GDP) of Thailand?
Give a very brief answer. 0.41. In the year 2001, what is the difference between the Rent(as % of GDP) in Sao Tome and Principe and Rent(as % of GDP) in Thailand?
Give a very brief answer. 2.33. In the year 2002, what is the difference between the Rent(as % of GDP) of Norway and Rent(as % of GDP) of Pakistan?
Provide a succinct answer. -0.97. In the year 2002, what is the difference between the Rent(as % of GDP) of Norway and Rent(as % of GDP) of Sao Tome and Principe?
Offer a terse response. -3.06. In the year 2002, what is the difference between the Rent(as % of GDP) of Norway and Rent(as % of GDP) of Thailand?
Offer a very short reply. -0.44. In the year 2002, what is the difference between the Rent(as % of GDP) in Pakistan and Rent(as % of GDP) in Sao Tome and Principe?
Provide a succinct answer. -2.1. In the year 2002, what is the difference between the Rent(as % of GDP) of Pakistan and Rent(as % of GDP) of Thailand?
Make the answer very short. 0.53. In the year 2002, what is the difference between the Rent(as % of GDP) of Sao Tome and Principe and Rent(as % of GDP) of Thailand?
Offer a terse response. 2.63. In the year 2003, what is the difference between the Rent(as % of GDP) in Norway and Rent(as % of GDP) in Pakistan?
Provide a short and direct response. -0.93. In the year 2003, what is the difference between the Rent(as % of GDP) in Norway and Rent(as % of GDP) in Sao Tome and Principe?
Your answer should be very brief. -3.93. In the year 2003, what is the difference between the Rent(as % of GDP) in Norway and Rent(as % of GDP) in Thailand?
Ensure brevity in your answer.  -0.92. In the year 2003, what is the difference between the Rent(as % of GDP) of Pakistan and Rent(as % of GDP) of Sao Tome and Principe?
Offer a very short reply. -3. In the year 2003, what is the difference between the Rent(as % of GDP) in Pakistan and Rent(as % of GDP) in Thailand?
Offer a terse response. 0.01. In the year 2003, what is the difference between the Rent(as % of GDP) of Sao Tome and Principe and Rent(as % of GDP) of Thailand?
Provide a short and direct response. 3.01. In the year 2004, what is the difference between the Rent(as % of GDP) in Norway and Rent(as % of GDP) in Pakistan?
Your response must be concise. -0.58. In the year 2004, what is the difference between the Rent(as % of GDP) of Norway and Rent(as % of GDP) of Sao Tome and Principe?
Give a very brief answer. -3.06. In the year 2004, what is the difference between the Rent(as % of GDP) in Norway and Rent(as % of GDP) in Thailand?
Give a very brief answer. -0.6. In the year 2004, what is the difference between the Rent(as % of GDP) in Pakistan and Rent(as % of GDP) in Sao Tome and Principe?
Keep it short and to the point. -2.48. In the year 2004, what is the difference between the Rent(as % of GDP) in Pakistan and Rent(as % of GDP) in Thailand?
Keep it short and to the point. -0.02. In the year 2004, what is the difference between the Rent(as % of GDP) of Sao Tome and Principe and Rent(as % of GDP) of Thailand?
Keep it short and to the point. 2.46. In the year 2005, what is the difference between the Rent(as % of GDP) in Norway and Rent(as % of GDP) in Pakistan?
Provide a short and direct response. -0.51. In the year 2005, what is the difference between the Rent(as % of GDP) of Norway and Rent(as % of GDP) of Sao Tome and Principe?
Provide a succinct answer. -2.9. In the year 2005, what is the difference between the Rent(as % of GDP) in Norway and Rent(as % of GDP) in Thailand?
Provide a succinct answer. -0.55. In the year 2005, what is the difference between the Rent(as % of GDP) of Pakistan and Rent(as % of GDP) of Sao Tome and Principe?
Make the answer very short. -2.39. In the year 2005, what is the difference between the Rent(as % of GDP) of Pakistan and Rent(as % of GDP) of Thailand?
Your answer should be very brief. -0.04. In the year 2005, what is the difference between the Rent(as % of GDP) of Sao Tome and Principe and Rent(as % of GDP) of Thailand?
Your response must be concise. 2.35. In the year 2006, what is the difference between the Rent(as % of GDP) of Norway and Rent(as % of GDP) of Pakistan?
Provide a succinct answer. -0.63. In the year 2006, what is the difference between the Rent(as % of GDP) of Norway and Rent(as % of GDP) of Sao Tome and Principe?
Offer a very short reply. -2.73. In the year 2006, what is the difference between the Rent(as % of GDP) of Norway and Rent(as % of GDP) of Thailand?
Ensure brevity in your answer.  -0.87. In the year 2006, what is the difference between the Rent(as % of GDP) in Pakistan and Rent(as % of GDP) in Sao Tome and Principe?
Provide a short and direct response. -2.1. In the year 2006, what is the difference between the Rent(as % of GDP) in Pakistan and Rent(as % of GDP) in Thailand?
Provide a succinct answer. -0.24. In the year 2006, what is the difference between the Rent(as % of GDP) of Sao Tome and Principe and Rent(as % of GDP) of Thailand?
Ensure brevity in your answer.  1.87. In the year 2007, what is the difference between the Rent(as % of GDP) in Norway and Rent(as % of GDP) in Pakistan?
Ensure brevity in your answer.  -0.94. In the year 2007, what is the difference between the Rent(as % of GDP) of Norway and Rent(as % of GDP) of Sao Tome and Principe?
Your answer should be very brief. -3.62. In the year 2007, what is the difference between the Rent(as % of GDP) of Norway and Rent(as % of GDP) of Thailand?
Offer a terse response. -0.75. In the year 2007, what is the difference between the Rent(as % of GDP) of Pakistan and Rent(as % of GDP) of Sao Tome and Principe?
Provide a succinct answer. -2.69. In the year 2007, what is the difference between the Rent(as % of GDP) of Pakistan and Rent(as % of GDP) of Thailand?
Offer a terse response. 0.18. In the year 2007, what is the difference between the Rent(as % of GDP) in Sao Tome and Principe and Rent(as % of GDP) in Thailand?
Your answer should be very brief. 2.87. In the year 2008, what is the difference between the Rent(as % of GDP) of Norway and Rent(as % of GDP) of Pakistan?
Your answer should be very brief. -0.79. In the year 2008, what is the difference between the Rent(as % of GDP) of Norway and Rent(as % of GDP) of Sao Tome and Principe?
Your response must be concise. -3.52. In the year 2008, what is the difference between the Rent(as % of GDP) of Norway and Rent(as % of GDP) of Thailand?
Make the answer very short. -0.89. In the year 2008, what is the difference between the Rent(as % of GDP) in Pakistan and Rent(as % of GDP) in Sao Tome and Principe?
Your response must be concise. -2.73. In the year 2008, what is the difference between the Rent(as % of GDP) in Pakistan and Rent(as % of GDP) in Thailand?
Provide a short and direct response. -0.1. In the year 2008, what is the difference between the Rent(as % of GDP) of Sao Tome and Principe and Rent(as % of GDP) of Thailand?
Offer a terse response. 2.63. What is the ratio of the Rent(as % of GDP) in Norway in 2001 to that in 2002?
Provide a succinct answer. 0.85. What is the ratio of the Rent(as % of GDP) of Pakistan in 2001 to that in 2002?
Your response must be concise. 0.91. What is the ratio of the Rent(as % of GDP) of Sao Tome and Principe in 2001 to that in 2002?
Ensure brevity in your answer.  0.91. What is the ratio of the Rent(as % of GDP) of Thailand in 2001 to that in 2002?
Provide a short and direct response. 1.03. What is the ratio of the Rent(as % of GDP) of Norway in 2001 to that in 2003?
Offer a terse response. 1.12. What is the ratio of the Rent(as % of GDP) of Pakistan in 2001 to that in 2003?
Make the answer very short. 0.98. What is the ratio of the Rent(as % of GDP) in Sao Tome and Principe in 2001 to that in 2003?
Offer a very short reply. 0.73. What is the ratio of the Rent(as % of GDP) in Thailand in 2001 to that in 2003?
Offer a very short reply. 0.59. What is the ratio of the Rent(as % of GDP) of Norway in 2001 to that in 2004?
Ensure brevity in your answer.  1.31. What is the ratio of the Rent(as % of GDP) in Pakistan in 2001 to that in 2004?
Your response must be concise. 1.51. What is the ratio of the Rent(as % of GDP) in Sao Tome and Principe in 2001 to that in 2004?
Offer a very short reply. 0.93. What is the ratio of the Rent(as % of GDP) in Thailand in 2001 to that in 2004?
Offer a terse response. 0.88. What is the ratio of the Rent(as % of GDP) of Norway in 2001 to that in 2005?
Make the answer very short. 1.3. What is the ratio of the Rent(as % of GDP) in Pakistan in 2001 to that in 2005?
Provide a short and direct response. 1.68. What is the ratio of the Rent(as % of GDP) in Sao Tome and Principe in 2001 to that in 2005?
Provide a short and direct response. 0.98. What is the ratio of the Rent(as % of GDP) in Thailand in 2001 to that in 2005?
Make the answer very short. 0.95. What is the ratio of the Rent(as % of GDP) of Norway in 2001 to that in 2006?
Ensure brevity in your answer.  1.3. What is the ratio of the Rent(as % of GDP) in Pakistan in 2001 to that in 2006?
Your answer should be compact. 1.4. What is the ratio of the Rent(as % of GDP) in Sao Tome and Principe in 2001 to that in 2006?
Keep it short and to the point. 1.04. What is the ratio of the Rent(as % of GDP) of Thailand in 2001 to that in 2006?
Your answer should be very brief. 0.64. What is the ratio of the Rent(as % of GDP) in Norway in 2001 to that in 2007?
Offer a very short reply. 1.14. What is the ratio of the Rent(as % of GDP) in Pakistan in 2001 to that in 2007?
Provide a succinct answer. 0.97. What is the ratio of the Rent(as % of GDP) of Sao Tome and Principe in 2001 to that in 2007?
Your response must be concise. 0.79. What is the ratio of the Rent(as % of GDP) of Thailand in 2001 to that in 2007?
Provide a succinct answer. 0.71. What is the ratio of the Rent(as % of GDP) in Norway in 2001 to that in 2008?
Ensure brevity in your answer.  1.19. What is the ratio of the Rent(as % of GDP) in Pakistan in 2001 to that in 2008?
Offer a very short reply. 1.13. What is the ratio of the Rent(as % of GDP) of Sao Tome and Principe in 2001 to that in 2008?
Your response must be concise. 0.81. What is the ratio of the Rent(as % of GDP) of Thailand in 2001 to that in 2008?
Give a very brief answer. 0.62. What is the ratio of the Rent(as % of GDP) in Norway in 2002 to that in 2003?
Keep it short and to the point. 1.31. What is the ratio of the Rent(as % of GDP) of Pakistan in 2002 to that in 2003?
Give a very brief answer. 1.07. What is the ratio of the Rent(as % of GDP) in Sao Tome and Principe in 2002 to that in 2003?
Keep it short and to the point. 0.8. What is the ratio of the Rent(as % of GDP) in Thailand in 2002 to that in 2003?
Give a very brief answer. 0.57. What is the ratio of the Rent(as % of GDP) in Norway in 2002 to that in 2004?
Give a very brief answer. 1.54. What is the ratio of the Rent(as % of GDP) in Pakistan in 2002 to that in 2004?
Keep it short and to the point. 1.66. What is the ratio of the Rent(as % of GDP) of Thailand in 2002 to that in 2004?
Your response must be concise. 0.85. What is the ratio of the Rent(as % of GDP) in Norway in 2002 to that in 2005?
Your answer should be very brief. 1.52. What is the ratio of the Rent(as % of GDP) of Pakistan in 2002 to that in 2005?
Give a very brief answer. 1.84. What is the ratio of the Rent(as % of GDP) in Sao Tome and Principe in 2002 to that in 2005?
Ensure brevity in your answer.  1.07. What is the ratio of the Rent(as % of GDP) in Thailand in 2002 to that in 2005?
Your response must be concise. 0.91. What is the ratio of the Rent(as % of GDP) in Norway in 2002 to that in 2006?
Provide a short and direct response. 1.53. What is the ratio of the Rent(as % of GDP) of Pakistan in 2002 to that in 2006?
Provide a succinct answer. 1.53. What is the ratio of the Rent(as % of GDP) in Sao Tome and Principe in 2002 to that in 2006?
Make the answer very short. 1.14. What is the ratio of the Rent(as % of GDP) of Thailand in 2002 to that in 2006?
Keep it short and to the point. 0.62. What is the ratio of the Rent(as % of GDP) of Norway in 2002 to that in 2007?
Your answer should be compact. 1.33. What is the ratio of the Rent(as % of GDP) in Pakistan in 2002 to that in 2007?
Your answer should be compact. 1.07. What is the ratio of the Rent(as % of GDP) of Sao Tome and Principe in 2002 to that in 2007?
Offer a very short reply. 0.86. What is the ratio of the Rent(as % of GDP) of Thailand in 2002 to that in 2007?
Ensure brevity in your answer.  0.68. What is the ratio of the Rent(as % of GDP) of Norway in 2002 to that in 2008?
Your answer should be very brief. 1.39. What is the ratio of the Rent(as % of GDP) in Pakistan in 2002 to that in 2008?
Ensure brevity in your answer.  1.24. What is the ratio of the Rent(as % of GDP) of Sao Tome and Principe in 2002 to that in 2008?
Provide a succinct answer. 0.89. What is the ratio of the Rent(as % of GDP) of Thailand in 2002 to that in 2008?
Keep it short and to the point. 0.59. What is the ratio of the Rent(as % of GDP) of Norway in 2003 to that in 2004?
Offer a very short reply. 1.18. What is the ratio of the Rent(as % of GDP) in Pakistan in 2003 to that in 2004?
Offer a terse response. 1.55. What is the ratio of the Rent(as % of GDP) of Sao Tome and Principe in 2003 to that in 2004?
Give a very brief answer. 1.28. What is the ratio of the Rent(as % of GDP) of Thailand in 2003 to that in 2004?
Your answer should be compact. 1.48. What is the ratio of the Rent(as % of GDP) in Norway in 2003 to that in 2005?
Keep it short and to the point. 1.16. What is the ratio of the Rent(as % of GDP) in Pakistan in 2003 to that in 2005?
Offer a terse response. 1.72. What is the ratio of the Rent(as % of GDP) of Sao Tome and Principe in 2003 to that in 2005?
Your answer should be compact. 1.35. What is the ratio of the Rent(as % of GDP) in Thailand in 2003 to that in 2005?
Provide a short and direct response. 1.59. What is the ratio of the Rent(as % of GDP) in Norway in 2003 to that in 2006?
Give a very brief answer. 1.17. What is the ratio of the Rent(as % of GDP) in Pakistan in 2003 to that in 2006?
Offer a very short reply. 1.43. What is the ratio of the Rent(as % of GDP) of Sao Tome and Principe in 2003 to that in 2006?
Your answer should be compact. 1.43. What is the ratio of the Rent(as % of GDP) in Thailand in 2003 to that in 2006?
Offer a terse response. 1.07. What is the ratio of the Rent(as % of GDP) of Norway in 2003 to that in 2007?
Provide a short and direct response. 1.02. What is the ratio of the Rent(as % of GDP) of Pakistan in 2003 to that in 2007?
Make the answer very short. 1. What is the ratio of the Rent(as % of GDP) in Sao Tome and Principe in 2003 to that in 2007?
Ensure brevity in your answer.  1.08. What is the ratio of the Rent(as % of GDP) in Thailand in 2003 to that in 2007?
Offer a very short reply. 1.19. What is the ratio of the Rent(as % of GDP) in Norway in 2003 to that in 2008?
Offer a very short reply. 1.06. What is the ratio of the Rent(as % of GDP) in Pakistan in 2003 to that in 2008?
Ensure brevity in your answer.  1.16. What is the ratio of the Rent(as % of GDP) of Sao Tome and Principe in 2003 to that in 2008?
Offer a terse response. 1.11. What is the ratio of the Rent(as % of GDP) of Thailand in 2003 to that in 2008?
Keep it short and to the point. 1.03. What is the ratio of the Rent(as % of GDP) in Norway in 2004 to that in 2005?
Your answer should be very brief. 0.99. What is the ratio of the Rent(as % of GDP) of Pakistan in 2004 to that in 2005?
Offer a very short reply. 1.11. What is the ratio of the Rent(as % of GDP) of Sao Tome and Principe in 2004 to that in 2005?
Provide a succinct answer. 1.05. What is the ratio of the Rent(as % of GDP) in Thailand in 2004 to that in 2005?
Make the answer very short. 1.07. What is the ratio of the Rent(as % of GDP) of Pakistan in 2004 to that in 2006?
Your response must be concise. 0.92. What is the ratio of the Rent(as % of GDP) of Sao Tome and Principe in 2004 to that in 2006?
Keep it short and to the point. 1.11. What is the ratio of the Rent(as % of GDP) in Thailand in 2004 to that in 2006?
Ensure brevity in your answer.  0.72. What is the ratio of the Rent(as % of GDP) in Norway in 2004 to that in 2007?
Ensure brevity in your answer.  0.87. What is the ratio of the Rent(as % of GDP) of Pakistan in 2004 to that in 2007?
Ensure brevity in your answer.  0.64. What is the ratio of the Rent(as % of GDP) in Sao Tome and Principe in 2004 to that in 2007?
Ensure brevity in your answer.  0.85. What is the ratio of the Rent(as % of GDP) of Thailand in 2004 to that in 2007?
Make the answer very short. 0.8. What is the ratio of the Rent(as % of GDP) in Norway in 2004 to that in 2008?
Ensure brevity in your answer.  0.9. What is the ratio of the Rent(as % of GDP) of Pakistan in 2004 to that in 2008?
Make the answer very short. 0.75. What is the ratio of the Rent(as % of GDP) in Sao Tome and Principe in 2004 to that in 2008?
Offer a very short reply. 0.87. What is the ratio of the Rent(as % of GDP) of Thailand in 2004 to that in 2008?
Keep it short and to the point. 0.7. What is the ratio of the Rent(as % of GDP) in Pakistan in 2005 to that in 2006?
Make the answer very short. 0.83. What is the ratio of the Rent(as % of GDP) of Sao Tome and Principe in 2005 to that in 2006?
Give a very brief answer. 1.06. What is the ratio of the Rent(as % of GDP) of Thailand in 2005 to that in 2006?
Keep it short and to the point. 0.67. What is the ratio of the Rent(as % of GDP) of Norway in 2005 to that in 2007?
Give a very brief answer. 0.88. What is the ratio of the Rent(as % of GDP) in Pakistan in 2005 to that in 2007?
Your response must be concise. 0.58. What is the ratio of the Rent(as % of GDP) in Sao Tome and Principe in 2005 to that in 2007?
Your answer should be compact. 0.8. What is the ratio of the Rent(as % of GDP) of Thailand in 2005 to that in 2007?
Give a very brief answer. 0.75. What is the ratio of the Rent(as % of GDP) in Norway in 2005 to that in 2008?
Your answer should be very brief. 0.91. What is the ratio of the Rent(as % of GDP) of Pakistan in 2005 to that in 2008?
Ensure brevity in your answer.  0.68. What is the ratio of the Rent(as % of GDP) in Sao Tome and Principe in 2005 to that in 2008?
Provide a succinct answer. 0.83. What is the ratio of the Rent(as % of GDP) in Thailand in 2005 to that in 2008?
Your answer should be very brief. 0.65. What is the ratio of the Rent(as % of GDP) of Norway in 2006 to that in 2007?
Keep it short and to the point. 0.87. What is the ratio of the Rent(as % of GDP) in Pakistan in 2006 to that in 2007?
Your answer should be compact. 0.7. What is the ratio of the Rent(as % of GDP) in Sao Tome and Principe in 2006 to that in 2007?
Offer a very short reply. 0.76. What is the ratio of the Rent(as % of GDP) in Thailand in 2006 to that in 2007?
Offer a terse response. 1.11. What is the ratio of the Rent(as % of GDP) of Norway in 2006 to that in 2008?
Provide a short and direct response. 0.91. What is the ratio of the Rent(as % of GDP) in Pakistan in 2006 to that in 2008?
Offer a very short reply. 0.81. What is the ratio of the Rent(as % of GDP) in Sao Tome and Principe in 2006 to that in 2008?
Your answer should be very brief. 0.78. What is the ratio of the Rent(as % of GDP) in Thailand in 2006 to that in 2008?
Your answer should be very brief. 0.97. What is the ratio of the Rent(as % of GDP) of Norway in 2007 to that in 2008?
Make the answer very short. 1.04. What is the ratio of the Rent(as % of GDP) in Pakistan in 2007 to that in 2008?
Provide a succinct answer. 1.17. What is the ratio of the Rent(as % of GDP) of Sao Tome and Principe in 2007 to that in 2008?
Provide a short and direct response. 1.03. What is the ratio of the Rent(as % of GDP) in Thailand in 2007 to that in 2008?
Keep it short and to the point. 0.87. What is the difference between the highest and the second highest Rent(as % of GDP) in Norway?
Offer a terse response. 0.02. What is the difference between the highest and the second highest Rent(as % of GDP) of Pakistan?
Your answer should be compact. 0.07. What is the difference between the highest and the second highest Rent(as % of GDP) of Sao Tome and Principe?
Offer a terse response. 0.31. What is the difference between the highest and the second highest Rent(as % of GDP) in Thailand?
Your answer should be very brief. 0.03. What is the difference between the highest and the lowest Rent(as % of GDP) in Norway?
Give a very brief answer. 0.05. What is the difference between the highest and the lowest Rent(as % of GDP) of Pakistan?
Provide a succinct answer. 0.51. What is the difference between the highest and the lowest Rent(as % of GDP) of Sao Tome and Principe?
Keep it short and to the point. 1.21. What is the difference between the highest and the lowest Rent(as % of GDP) in Thailand?
Offer a very short reply. 0.44. 